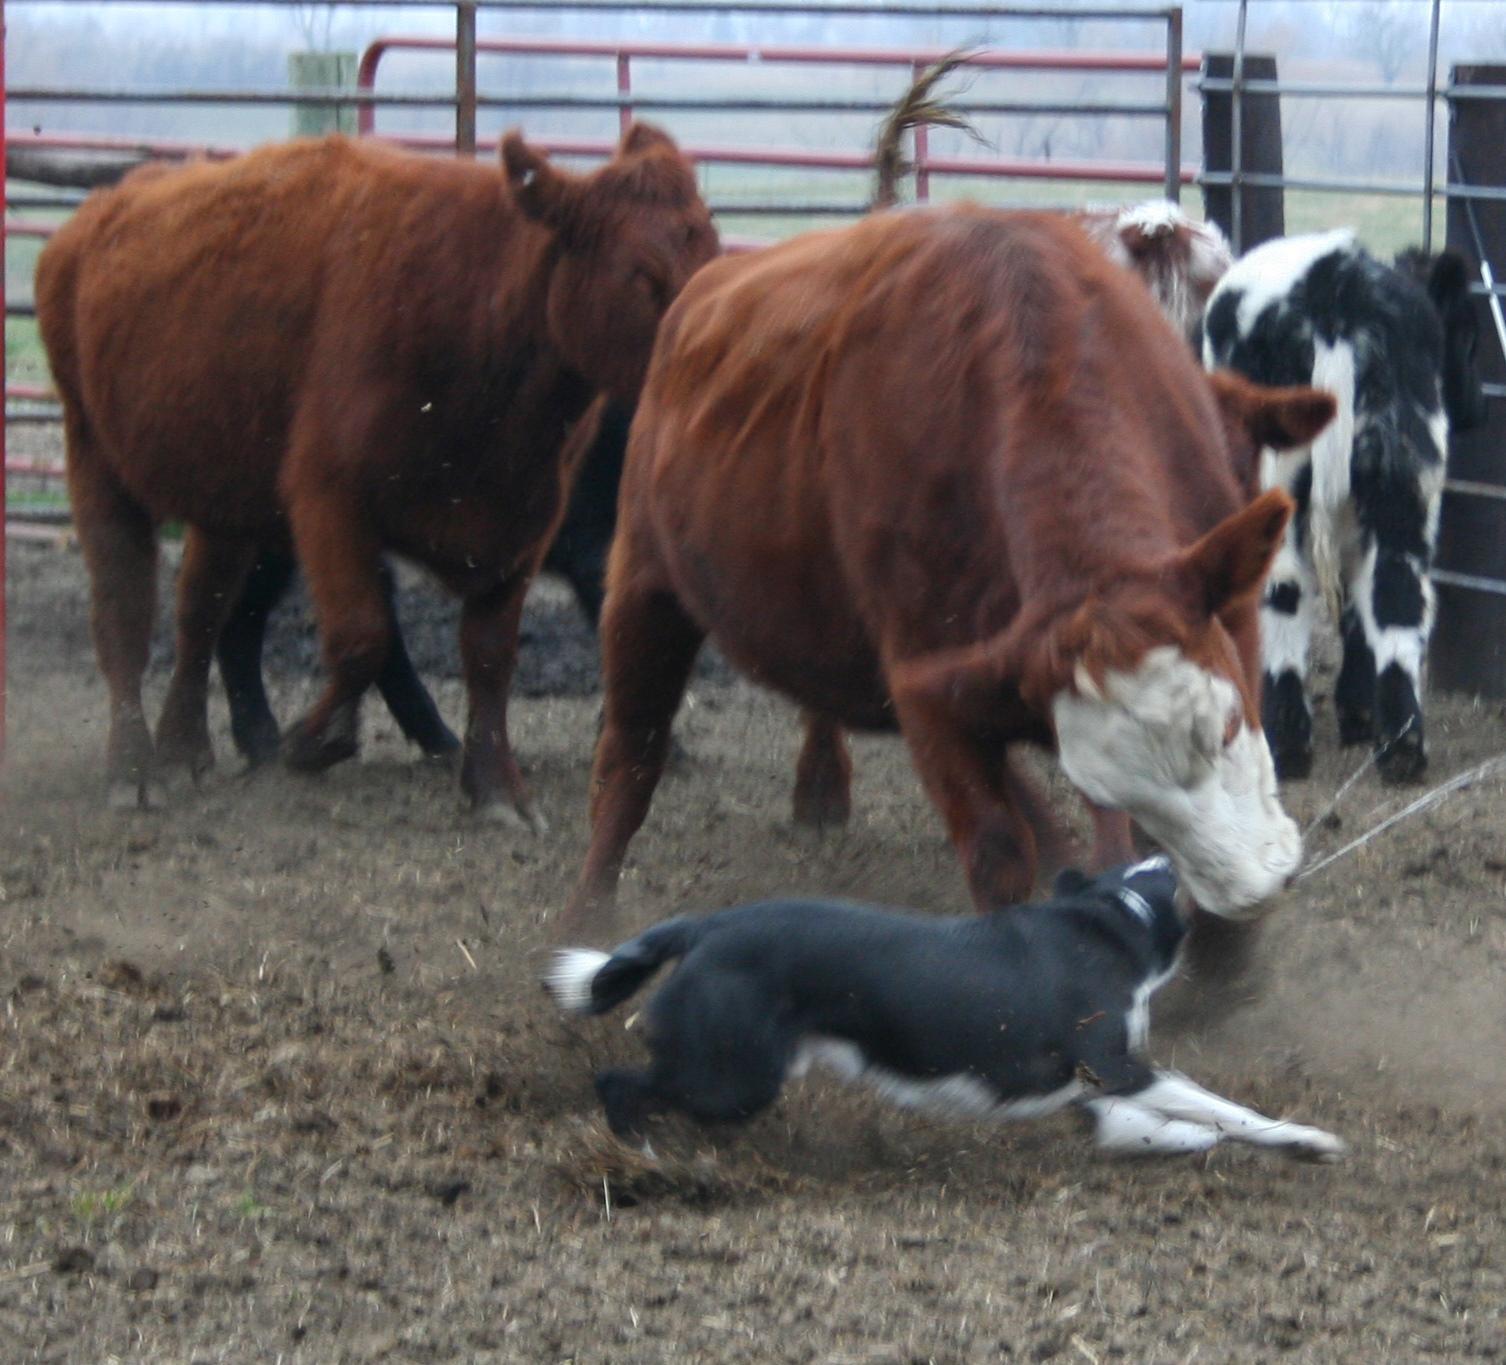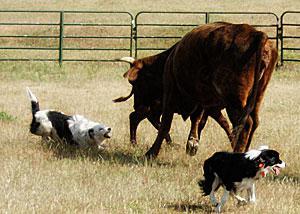The first image is the image on the left, the second image is the image on the right. Assess this claim about the two images: "Dogs herd livestock within a fence line.". Correct or not? Answer yes or no. Yes. The first image is the image on the left, the second image is the image on the right. Considering the images on both sides, is "The dog in the left image is facing towards the left." valid? Answer yes or no. No. 